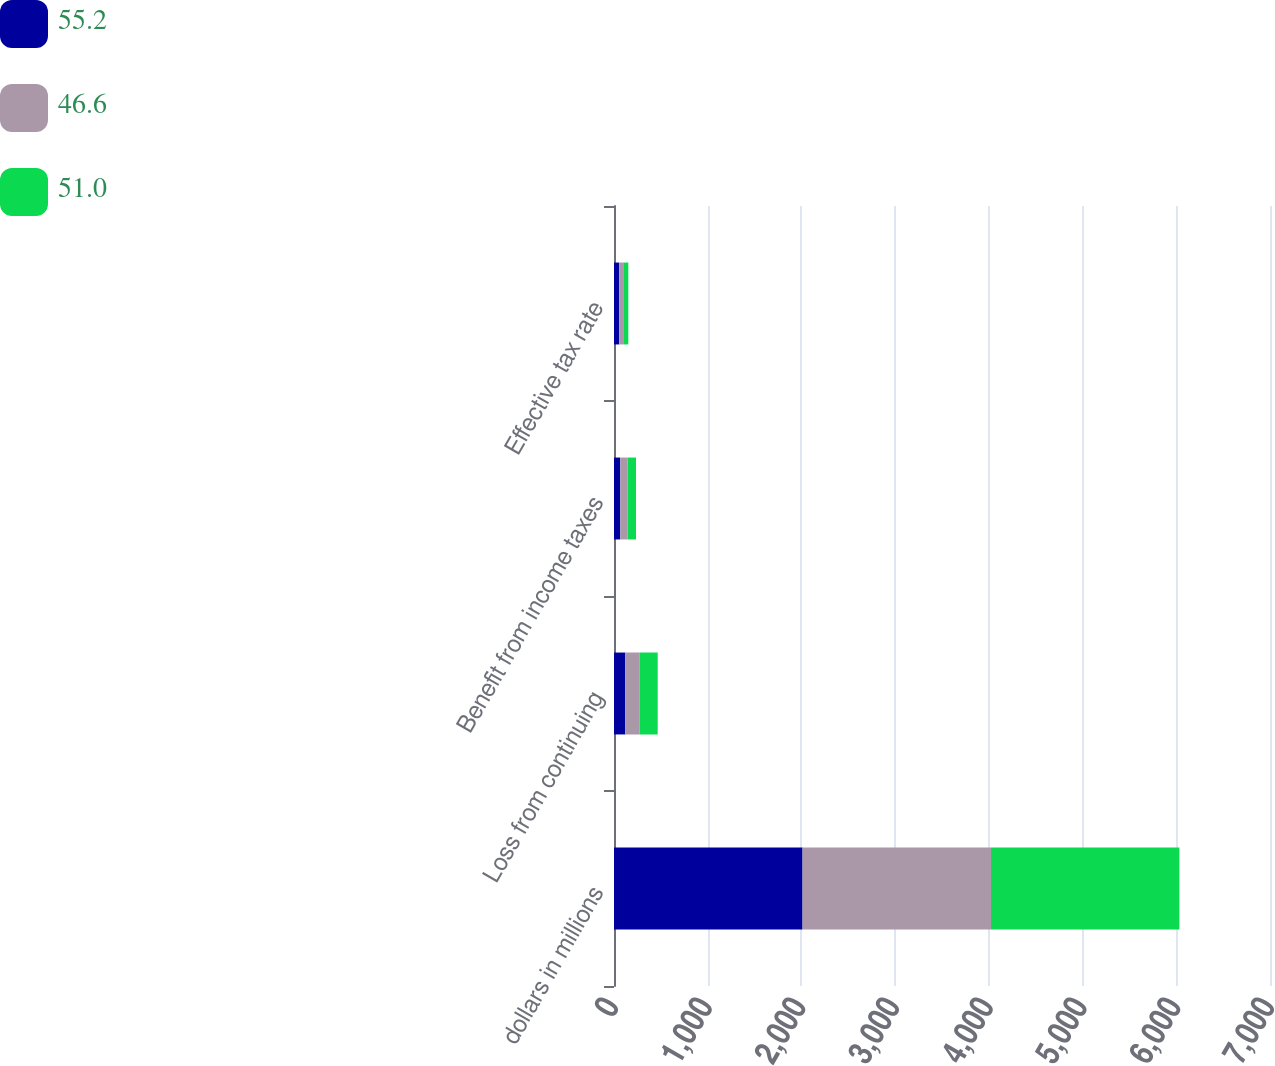Convert chart. <chart><loc_0><loc_0><loc_500><loc_500><stacked_bar_chart><ecel><fcel>dollars in millions<fcel>Loss from continuing<fcel>Benefit from income taxes<fcel>Effective tax rate<nl><fcel>55.2<fcel>2012<fcel>120.4<fcel>66.5<fcel>55.2<nl><fcel>46.6<fcel>2011<fcel>153.7<fcel>78.5<fcel>51<nl><fcel>51<fcel>2010<fcel>192.2<fcel>89.7<fcel>46.6<nl></chart> 